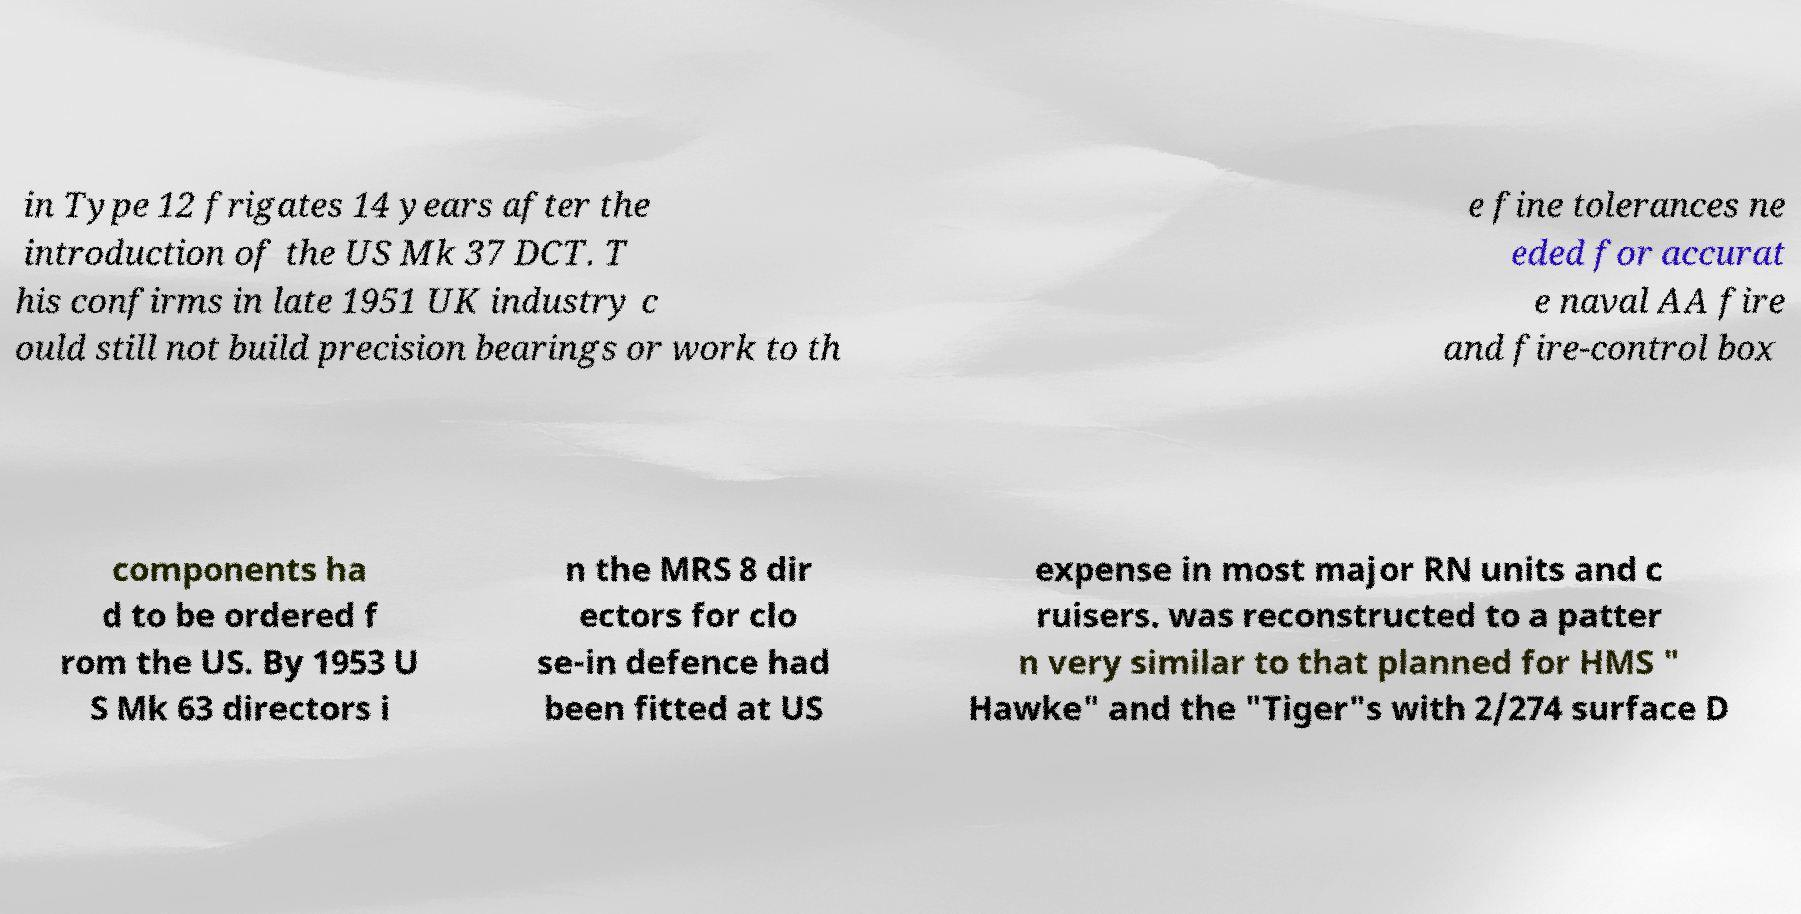Can you accurately transcribe the text from the provided image for me? in Type 12 frigates 14 years after the introduction of the US Mk 37 DCT. T his confirms in late 1951 UK industry c ould still not build precision bearings or work to th e fine tolerances ne eded for accurat e naval AA fire and fire-control box components ha d to be ordered f rom the US. By 1953 U S Mk 63 directors i n the MRS 8 dir ectors for clo se-in defence had been fitted at US expense in most major RN units and c ruisers. was reconstructed to a patter n very similar to that planned for HMS " Hawke" and the "Tiger"s with 2/274 surface D 